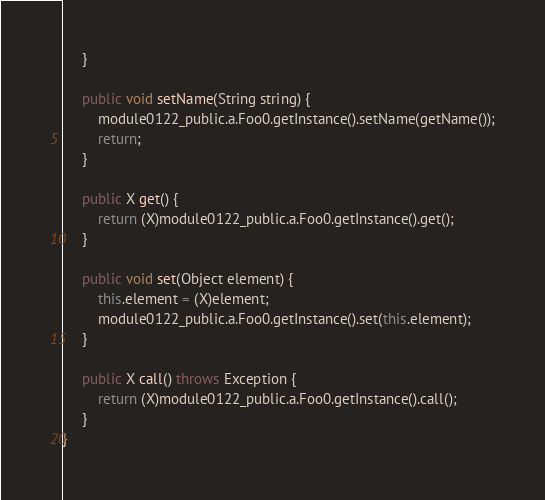Convert code to text. <code><loc_0><loc_0><loc_500><loc_500><_Java_>	 }

	 public void setName(String string) {
	 	 module0122_public.a.Foo0.getInstance().setName(getName());
	 	 return;
	 }

	 public X get() {
	 	 return (X)module0122_public.a.Foo0.getInstance().get();
	 }

	 public void set(Object element) {
	 	 this.element = (X)element;
	 	 module0122_public.a.Foo0.getInstance().set(this.element);
	 }

	 public X call() throws Exception {
	 	 return (X)module0122_public.a.Foo0.getInstance().call();
	 }
}
</code> 